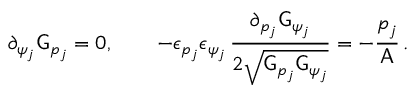<formula> <loc_0><loc_0><loc_500><loc_500>\partial _ { \psi _ { j } } G _ { p _ { j } } = 0 , \quad - \epsilon _ { p _ { j } } \epsilon _ { \psi _ { j } } \, \frac { \partial _ { p _ { j } } G _ { \psi _ { j } } } { 2 \sqrt { G _ { p _ { j } } G _ { \psi _ { j } } } } = - \frac { p _ { j } } { A } \, .</formula> 